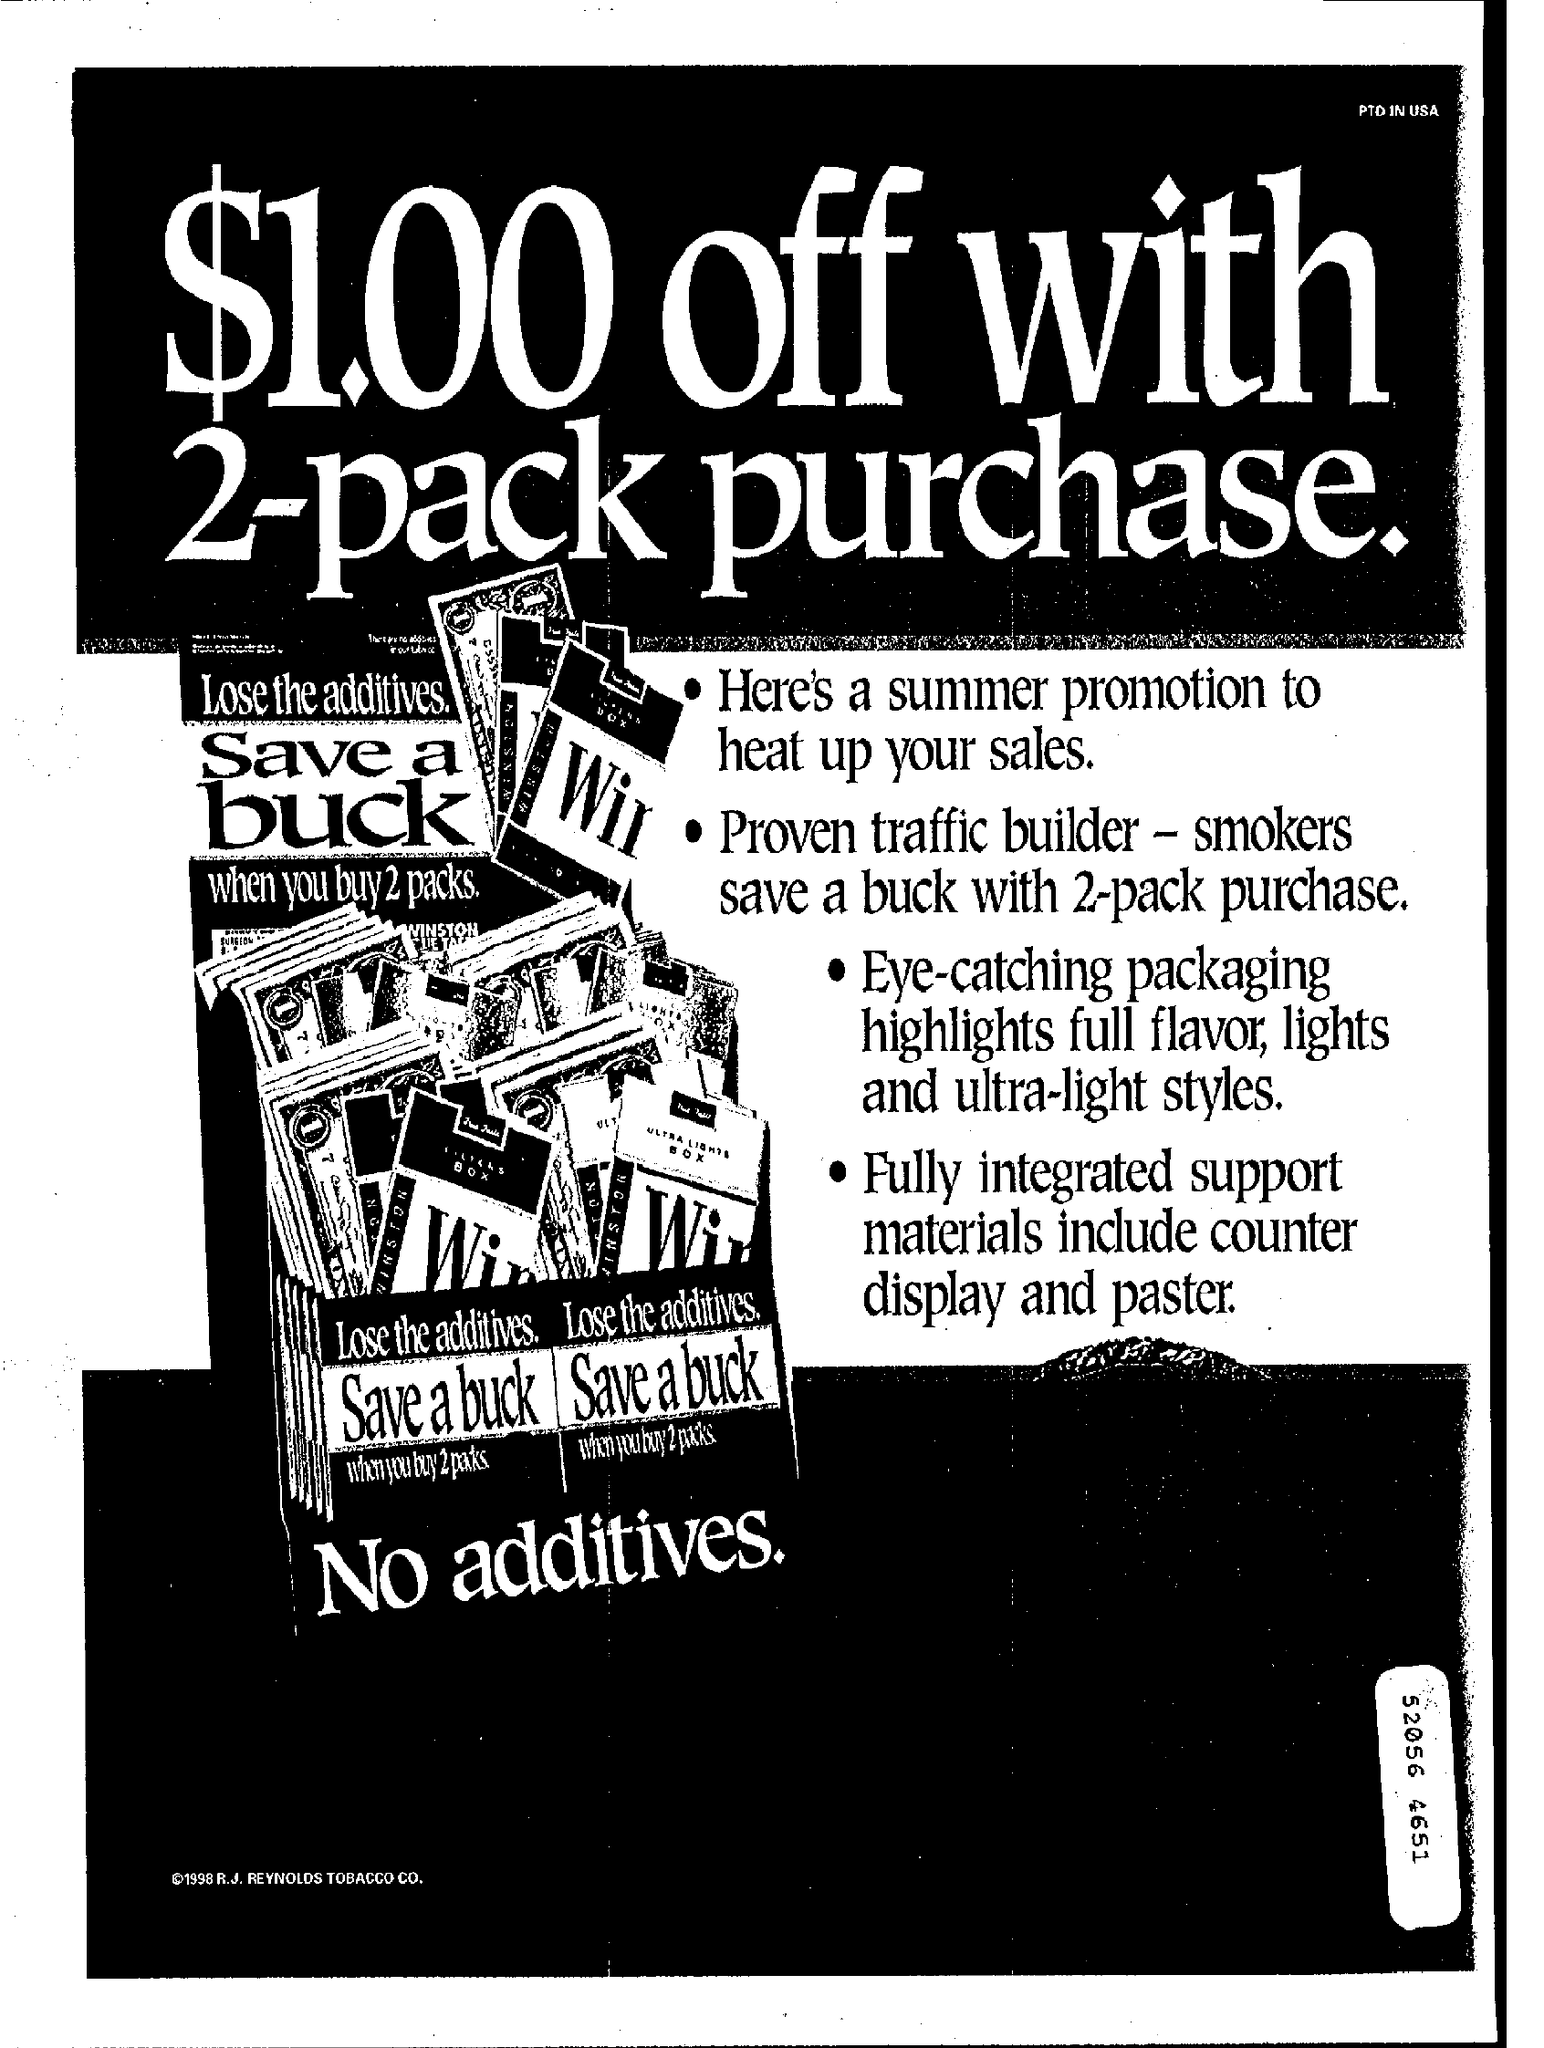What is the title of the document?
Ensure brevity in your answer.  $1.00 off with 2-pack purchase. What is at the top-right of the document?
Your answer should be very brief. PTD IN USA. 